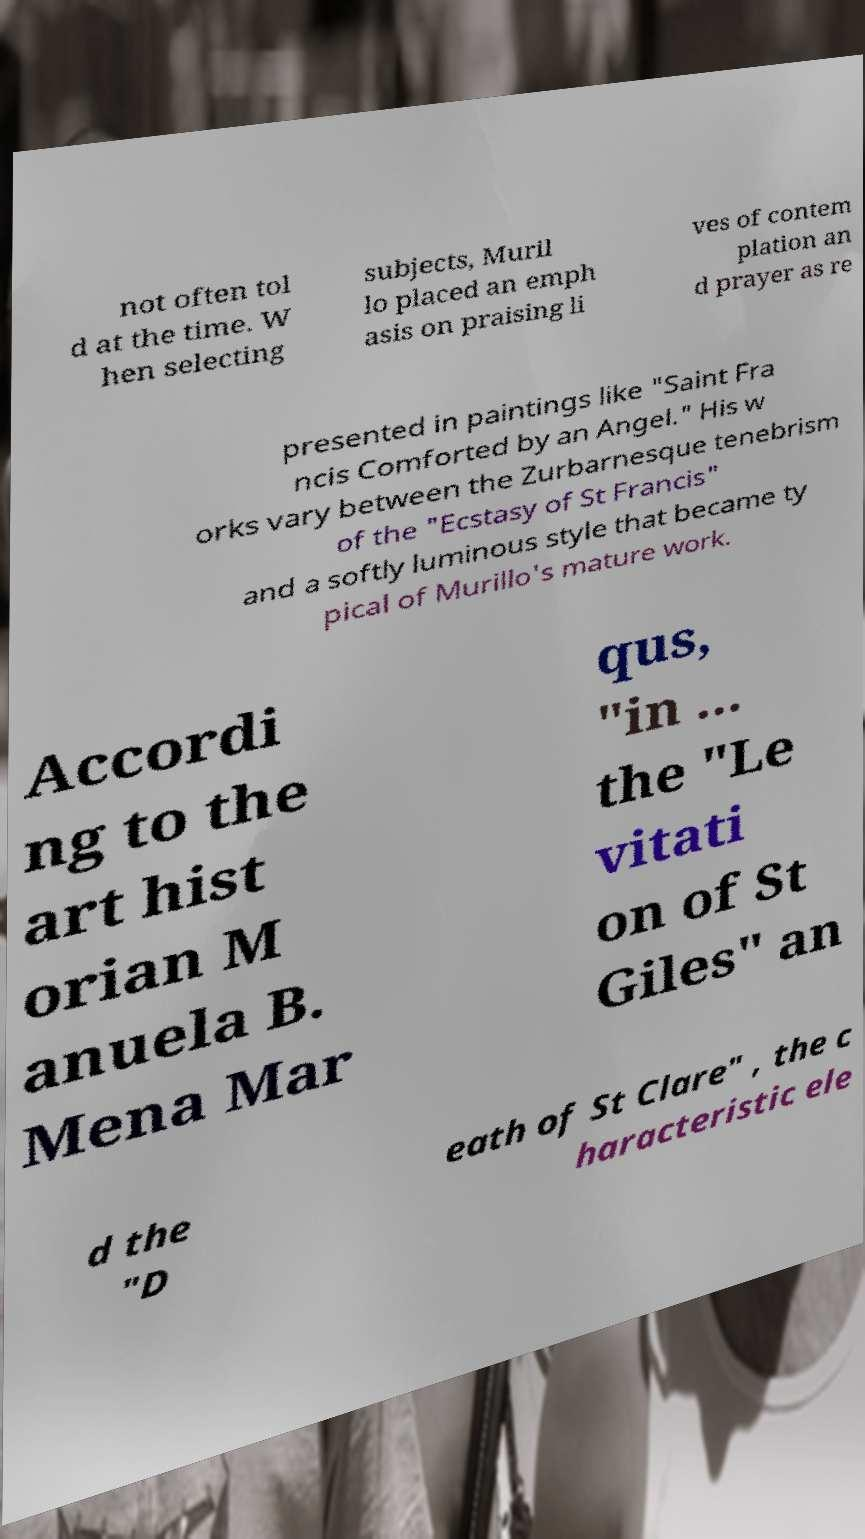Could you assist in decoding the text presented in this image and type it out clearly? not often tol d at the time. W hen selecting subjects, Muril lo placed an emph asis on praising li ves of contem plation an d prayer as re presented in paintings like "Saint Fra ncis Comforted by an Angel." His w orks vary between the Zurbarnesque tenebrism of the "Ecstasy of St Francis" and a softly luminous style that became ty pical of Murillo's mature work. Accordi ng to the art hist orian M anuela B. Mena Mar qus, "in ... the "Le vitati on of St Giles" an d the "D eath of St Clare" , the c haracteristic ele 